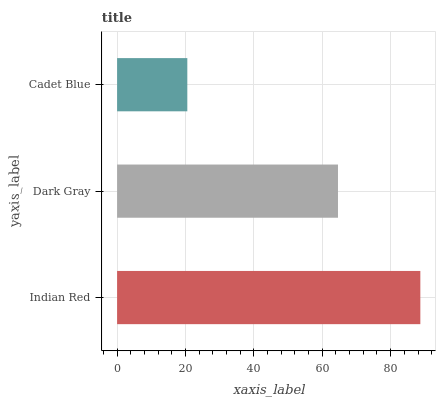Is Cadet Blue the minimum?
Answer yes or no. Yes. Is Indian Red the maximum?
Answer yes or no. Yes. Is Dark Gray the minimum?
Answer yes or no. No. Is Dark Gray the maximum?
Answer yes or no. No. Is Indian Red greater than Dark Gray?
Answer yes or no. Yes. Is Dark Gray less than Indian Red?
Answer yes or no. Yes. Is Dark Gray greater than Indian Red?
Answer yes or no. No. Is Indian Red less than Dark Gray?
Answer yes or no. No. Is Dark Gray the high median?
Answer yes or no. Yes. Is Dark Gray the low median?
Answer yes or no. Yes. Is Indian Red the high median?
Answer yes or no. No. Is Cadet Blue the low median?
Answer yes or no. No. 